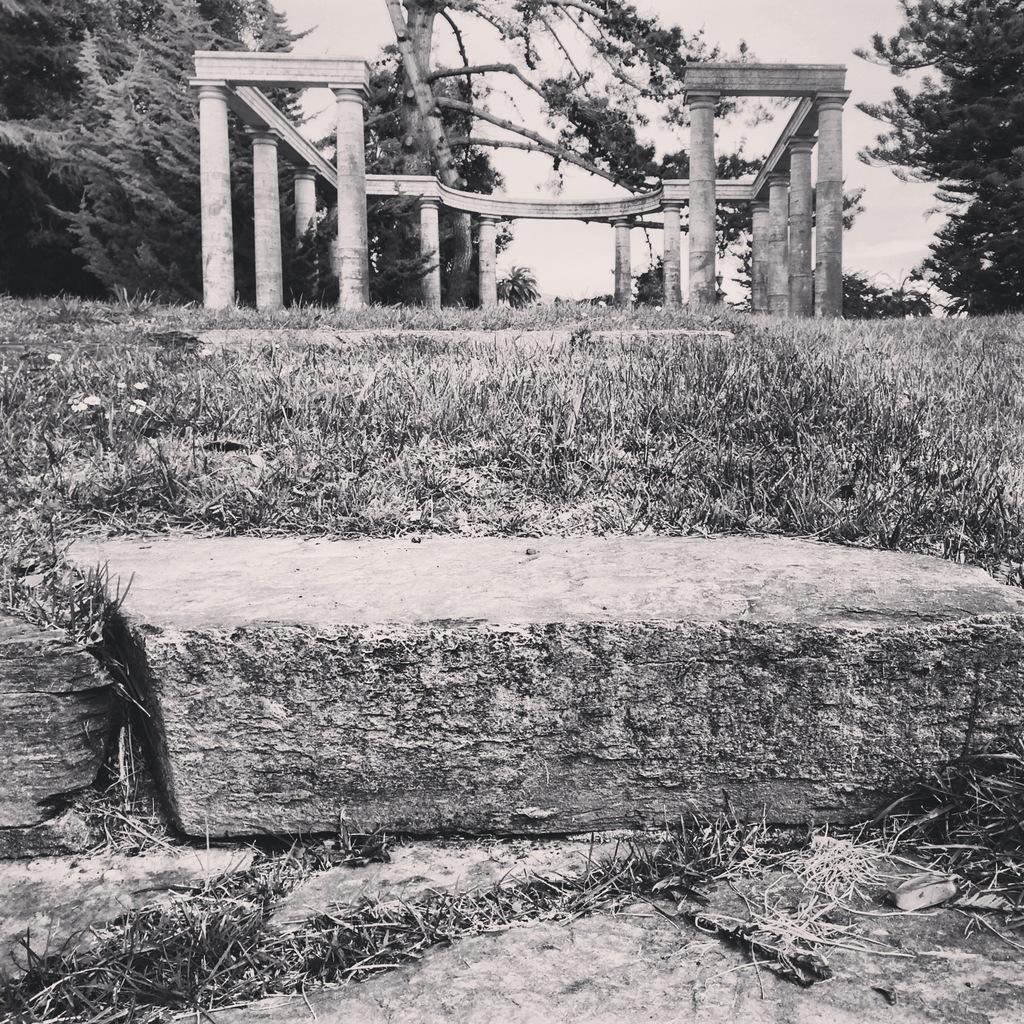What is the color scheme of the image? The image is black and white. What type of landscape can be seen in the front of the image? There is grassland in the front of the image. What is happening in the back of the image? There is construction in the back of the image. What type of vegetation surrounds the construction site? Trees are present on either side of the construction. What type of paste is being used to hold the vessel together in the image? There is no vessel or paste present in the image. 